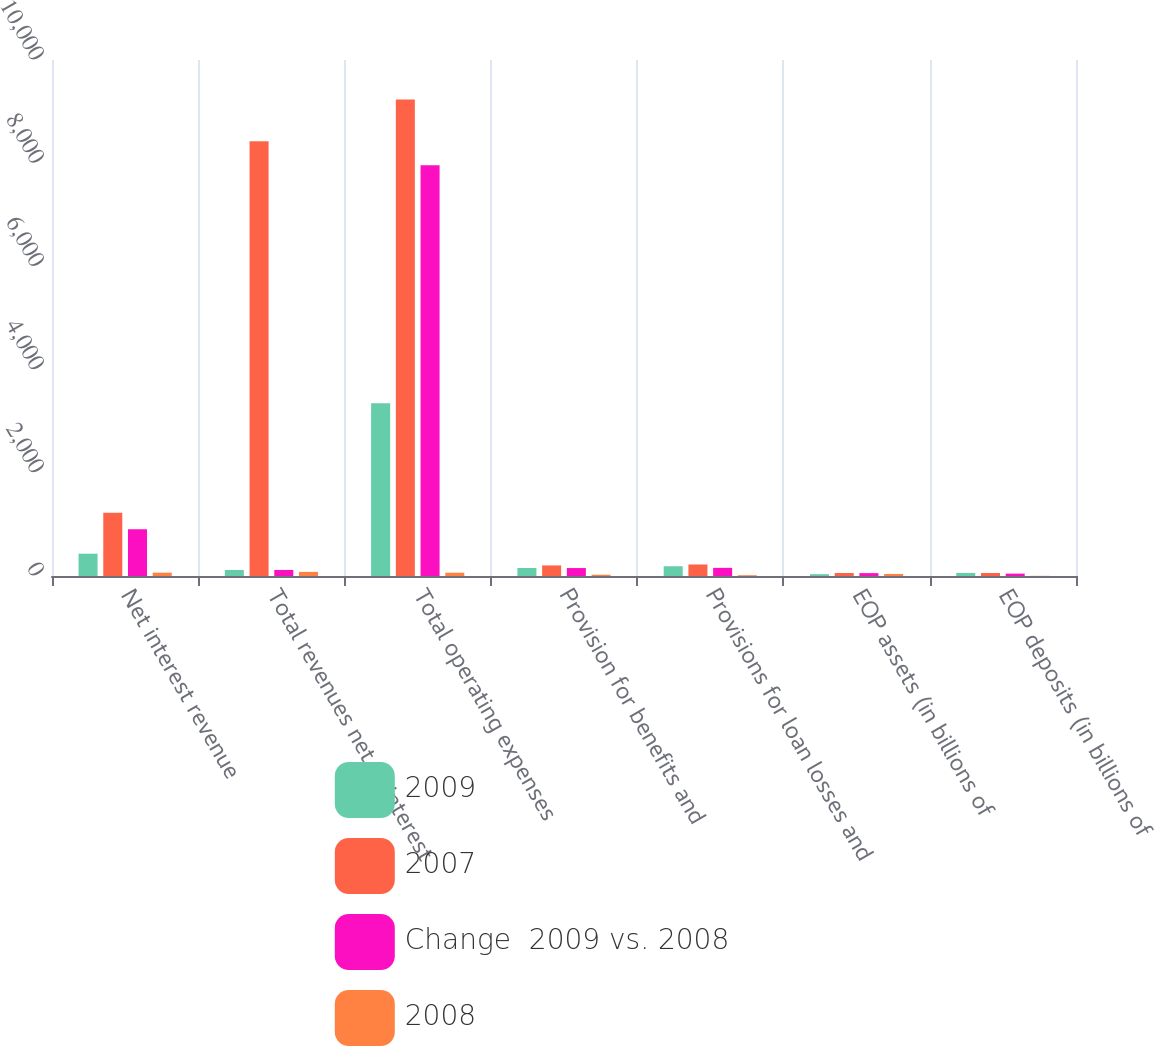<chart> <loc_0><loc_0><loc_500><loc_500><stacked_bar_chart><ecel><fcel>Net interest revenue<fcel>Total revenues net of interest<fcel>Total operating expenses<fcel>Provision for benefits and<fcel>Provisions for loan losses and<fcel>EOP assets (in billions of<fcel>EOP deposits (in billions of<nl><fcel>2009<fcel>432<fcel>117<fcel>3350<fcel>155<fcel>189<fcel>35<fcel>60<nl><fcel>2007<fcel>1224<fcel>8423<fcel>9236<fcel>205<fcel>223<fcel>58<fcel>58<nl><fcel>Change  2009 vs. 2008<fcel>908<fcel>117<fcel>7960<fcel>154<fcel>158<fcel>56<fcel>46<nl><fcel>2008<fcel>65<fcel>80<fcel>64<fcel>24<fcel>15<fcel>40<fcel>3<nl></chart> 